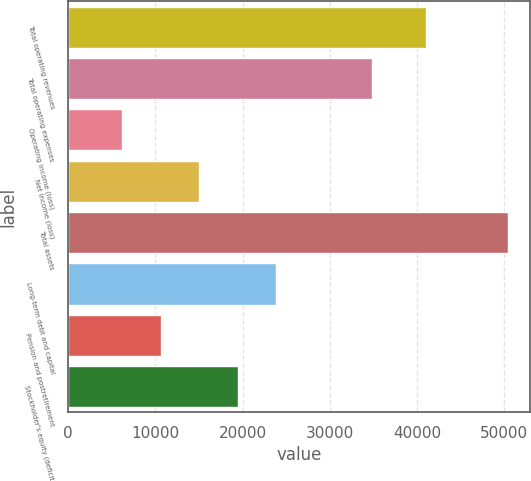<chart> <loc_0><loc_0><loc_500><loc_500><bar_chart><fcel>Total operating revenues<fcel>Total operating expenses<fcel>Operating income (loss)<fcel>Net income (loss)<fcel>Total assets<fcel>Long-term debt and capital<fcel>Pension and postretirement<fcel>Stockholder's equity (deficit)<nl><fcel>41084<fcel>34895<fcel>6189<fcel>15038.8<fcel>50438<fcel>23888.6<fcel>10613.9<fcel>19463.7<nl></chart> 